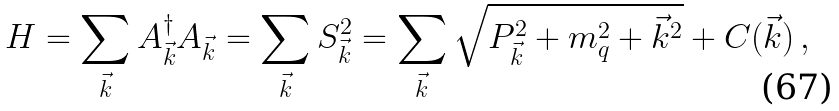Convert formula to latex. <formula><loc_0><loc_0><loc_500><loc_500>H = \sum _ { \vec { k } } A _ { \vec { k } } ^ { \dagger } A _ { \vec { k } } = \sum _ { \vec { k } } S _ { \vec { k } } ^ { 2 } = \sum _ { \vec { k } } \sqrt { P _ { \vec { k } } ^ { 2 } + m _ { q } ^ { 2 } + { \vec { k } } ^ { 2 } } + C ( \vec { k } ) \, ,</formula> 